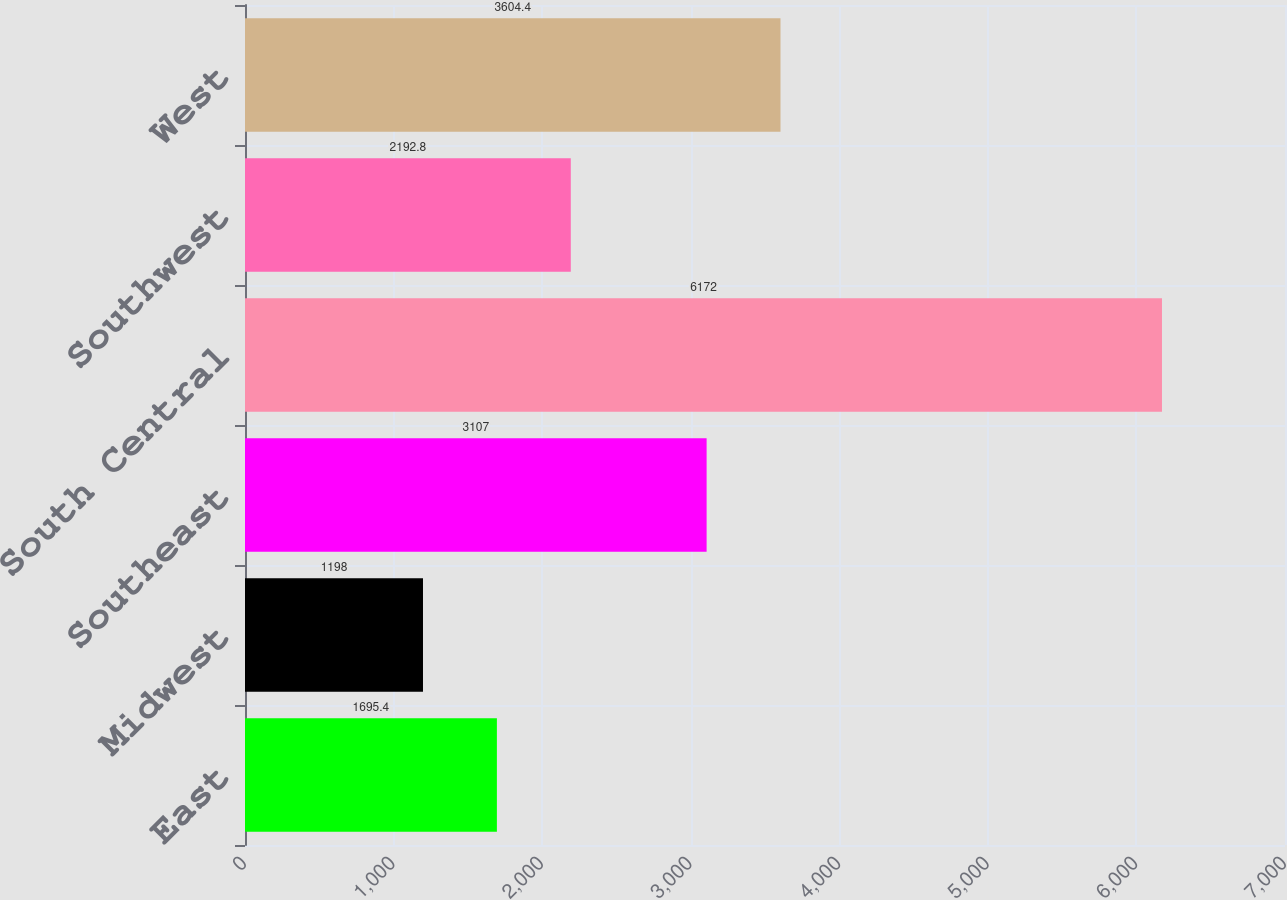<chart> <loc_0><loc_0><loc_500><loc_500><bar_chart><fcel>East<fcel>Midwest<fcel>Southeast<fcel>South Central<fcel>Southwest<fcel>West<nl><fcel>1695.4<fcel>1198<fcel>3107<fcel>6172<fcel>2192.8<fcel>3604.4<nl></chart> 